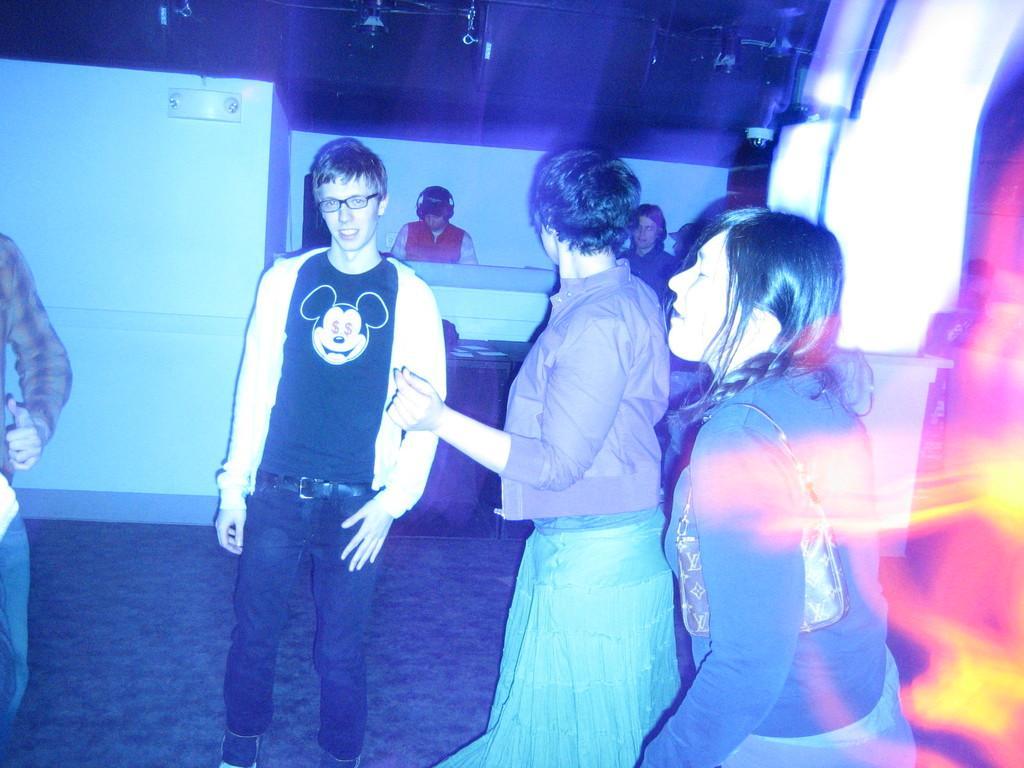How would you summarize this image in a sentence or two? In this image we can see a group of people standing on the floor. On the backside we can see two people wearing headset. We can also see a wall and a roof. 